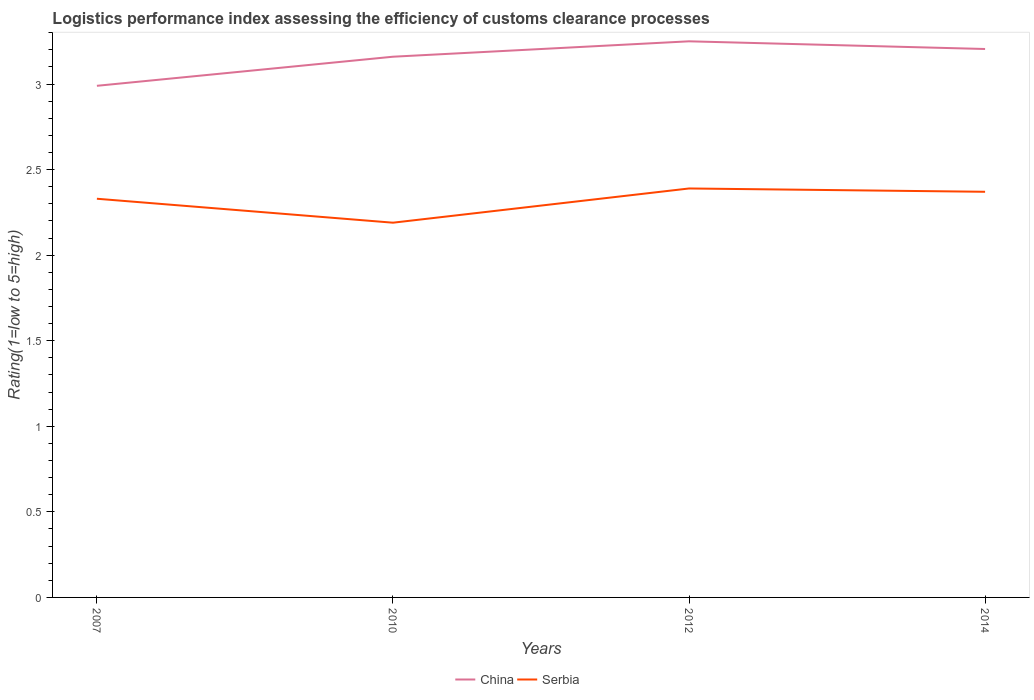How many different coloured lines are there?
Your response must be concise. 2. Does the line corresponding to China intersect with the line corresponding to Serbia?
Your answer should be compact. No. Is the number of lines equal to the number of legend labels?
Your answer should be compact. Yes. Across all years, what is the maximum Logistic performance index in China?
Ensure brevity in your answer.  2.99. What is the total Logistic performance index in China in the graph?
Your answer should be very brief. -0.09. What is the difference between the highest and the second highest Logistic performance index in Serbia?
Provide a succinct answer. 0.2. Is the Logistic performance index in Serbia strictly greater than the Logistic performance index in China over the years?
Your answer should be compact. Yes. How many lines are there?
Make the answer very short. 2. Does the graph contain grids?
Provide a succinct answer. No. What is the title of the graph?
Keep it short and to the point. Logistics performance index assessing the efficiency of customs clearance processes. What is the label or title of the Y-axis?
Offer a very short reply. Rating(1=low to 5=high). What is the Rating(1=low to 5=high) of China in 2007?
Offer a very short reply. 2.99. What is the Rating(1=low to 5=high) of Serbia in 2007?
Provide a succinct answer. 2.33. What is the Rating(1=low to 5=high) of China in 2010?
Provide a succinct answer. 3.16. What is the Rating(1=low to 5=high) of Serbia in 2010?
Your answer should be very brief. 2.19. What is the Rating(1=low to 5=high) in China in 2012?
Ensure brevity in your answer.  3.25. What is the Rating(1=low to 5=high) in Serbia in 2012?
Give a very brief answer. 2.39. What is the Rating(1=low to 5=high) in China in 2014?
Provide a succinct answer. 3.21. What is the Rating(1=low to 5=high) in Serbia in 2014?
Your answer should be very brief. 2.37. Across all years, what is the maximum Rating(1=low to 5=high) of China?
Give a very brief answer. 3.25. Across all years, what is the maximum Rating(1=low to 5=high) in Serbia?
Make the answer very short. 2.39. Across all years, what is the minimum Rating(1=low to 5=high) of China?
Make the answer very short. 2.99. Across all years, what is the minimum Rating(1=low to 5=high) of Serbia?
Keep it short and to the point. 2.19. What is the total Rating(1=low to 5=high) of China in the graph?
Offer a very short reply. 12.61. What is the total Rating(1=low to 5=high) of Serbia in the graph?
Your response must be concise. 9.28. What is the difference between the Rating(1=low to 5=high) of China in 2007 and that in 2010?
Offer a terse response. -0.17. What is the difference between the Rating(1=low to 5=high) of Serbia in 2007 and that in 2010?
Your answer should be very brief. 0.14. What is the difference between the Rating(1=low to 5=high) in China in 2007 and that in 2012?
Your answer should be very brief. -0.26. What is the difference between the Rating(1=low to 5=high) in Serbia in 2007 and that in 2012?
Keep it short and to the point. -0.06. What is the difference between the Rating(1=low to 5=high) in China in 2007 and that in 2014?
Your answer should be compact. -0.22. What is the difference between the Rating(1=low to 5=high) of Serbia in 2007 and that in 2014?
Your answer should be compact. -0.04. What is the difference between the Rating(1=low to 5=high) of China in 2010 and that in 2012?
Make the answer very short. -0.09. What is the difference between the Rating(1=low to 5=high) of China in 2010 and that in 2014?
Provide a succinct answer. -0.05. What is the difference between the Rating(1=low to 5=high) of Serbia in 2010 and that in 2014?
Your answer should be very brief. -0.18. What is the difference between the Rating(1=low to 5=high) of China in 2012 and that in 2014?
Your answer should be very brief. 0.04. What is the difference between the Rating(1=low to 5=high) of Serbia in 2012 and that in 2014?
Give a very brief answer. 0.02. What is the difference between the Rating(1=low to 5=high) in China in 2007 and the Rating(1=low to 5=high) in Serbia in 2014?
Your response must be concise. 0.62. What is the difference between the Rating(1=low to 5=high) in China in 2010 and the Rating(1=low to 5=high) in Serbia in 2012?
Ensure brevity in your answer.  0.77. What is the difference between the Rating(1=low to 5=high) in China in 2010 and the Rating(1=low to 5=high) in Serbia in 2014?
Give a very brief answer. 0.79. What is the difference between the Rating(1=low to 5=high) of China in 2012 and the Rating(1=low to 5=high) of Serbia in 2014?
Ensure brevity in your answer.  0.88. What is the average Rating(1=low to 5=high) in China per year?
Ensure brevity in your answer.  3.15. What is the average Rating(1=low to 5=high) of Serbia per year?
Your response must be concise. 2.32. In the year 2007, what is the difference between the Rating(1=low to 5=high) of China and Rating(1=low to 5=high) of Serbia?
Your answer should be compact. 0.66. In the year 2010, what is the difference between the Rating(1=low to 5=high) of China and Rating(1=low to 5=high) of Serbia?
Provide a succinct answer. 0.97. In the year 2012, what is the difference between the Rating(1=low to 5=high) of China and Rating(1=low to 5=high) of Serbia?
Ensure brevity in your answer.  0.86. In the year 2014, what is the difference between the Rating(1=low to 5=high) of China and Rating(1=low to 5=high) of Serbia?
Ensure brevity in your answer.  0.83. What is the ratio of the Rating(1=low to 5=high) in China in 2007 to that in 2010?
Offer a terse response. 0.95. What is the ratio of the Rating(1=low to 5=high) of Serbia in 2007 to that in 2010?
Offer a very short reply. 1.06. What is the ratio of the Rating(1=low to 5=high) of China in 2007 to that in 2012?
Make the answer very short. 0.92. What is the ratio of the Rating(1=low to 5=high) of Serbia in 2007 to that in 2012?
Ensure brevity in your answer.  0.97. What is the ratio of the Rating(1=low to 5=high) in China in 2007 to that in 2014?
Make the answer very short. 0.93. What is the ratio of the Rating(1=low to 5=high) in Serbia in 2007 to that in 2014?
Your answer should be compact. 0.98. What is the ratio of the Rating(1=low to 5=high) in China in 2010 to that in 2012?
Offer a terse response. 0.97. What is the ratio of the Rating(1=low to 5=high) in Serbia in 2010 to that in 2012?
Provide a succinct answer. 0.92. What is the ratio of the Rating(1=low to 5=high) of China in 2010 to that in 2014?
Provide a short and direct response. 0.99. What is the ratio of the Rating(1=low to 5=high) in Serbia in 2010 to that in 2014?
Provide a short and direct response. 0.92. What is the ratio of the Rating(1=low to 5=high) of Serbia in 2012 to that in 2014?
Make the answer very short. 1.01. What is the difference between the highest and the second highest Rating(1=low to 5=high) of China?
Ensure brevity in your answer.  0.04. What is the difference between the highest and the second highest Rating(1=low to 5=high) in Serbia?
Your answer should be very brief. 0.02. What is the difference between the highest and the lowest Rating(1=low to 5=high) of China?
Your response must be concise. 0.26. What is the difference between the highest and the lowest Rating(1=low to 5=high) in Serbia?
Provide a succinct answer. 0.2. 